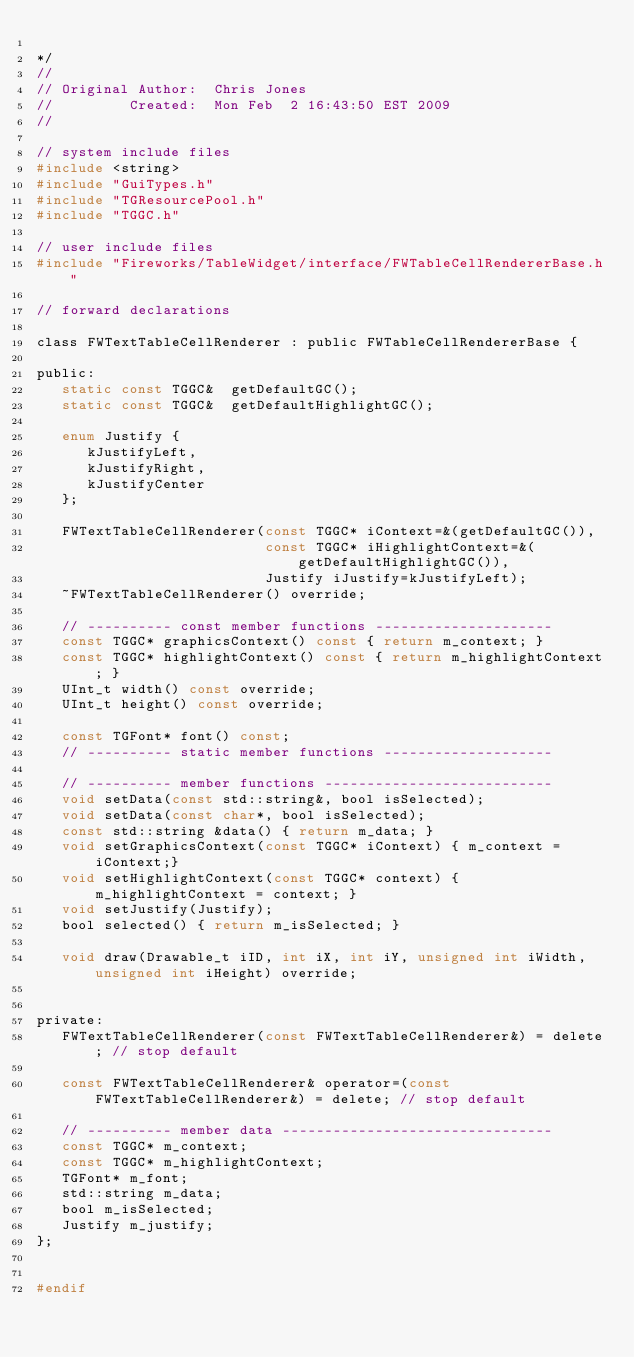<code> <loc_0><loc_0><loc_500><loc_500><_C_>
*/
//
// Original Author:  Chris Jones
//         Created:  Mon Feb  2 16:43:50 EST 2009
//

// system include files
#include <string>
#include "GuiTypes.h"
#include "TGResourcePool.h"
#include "TGGC.h"

// user include files
#include "Fireworks/TableWidget/interface/FWTableCellRendererBase.h"

// forward declarations

class FWTextTableCellRenderer : public FWTableCellRendererBase {
   
public:
   static const TGGC&  getDefaultGC();
   static const TGGC&  getDefaultHighlightGC();  
   
   enum Justify {
      kJustifyLeft,
      kJustifyRight,
      kJustifyCenter
   };
   
   FWTextTableCellRenderer(const TGGC* iContext=&(getDefaultGC()), 
                           const TGGC* iHighlightContext=&(getDefaultHighlightGC()),
                           Justify iJustify=kJustifyLeft);
   ~FWTextTableCellRenderer() override;
   
   // ---------- const member functions ---------------------
   const TGGC* graphicsContext() const { return m_context; }
   const TGGC* highlightContext() const { return m_highlightContext; }
   UInt_t width() const override;
   UInt_t height() const override;
   
   const TGFont* font() const;
   // ---------- static member functions --------------------
   
   // ---------- member functions ---------------------------
   void setData(const std::string&, bool isSelected);
   void setData(const char*, bool isSelected);
   const std::string &data() { return m_data; }
   void setGraphicsContext(const TGGC* iContext) { m_context = iContext;}
   void setHighlightContext(const TGGC* context) { m_highlightContext = context; }
   void setJustify(Justify);
   bool selected() { return m_isSelected; }
   
   void draw(Drawable_t iID, int iX, int iY, unsigned int iWidth, unsigned int iHeight) override;
   
   
private:
   FWTextTableCellRenderer(const FWTextTableCellRenderer&) = delete; // stop default
   
   const FWTextTableCellRenderer& operator=(const FWTextTableCellRenderer&) = delete; // stop default
   
   // ---------- member data --------------------------------
   const TGGC* m_context;
   const TGGC* m_highlightContext;
   TGFont* m_font;
   std::string m_data;
   bool m_isSelected;
   Justify m_justify;
};


#endif
</code> 